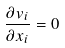Convert formula to latex. <formula><loc_0><loc_0><loc_500><loc_500>\frac { \partial v _ { i } } { \partial x _ { i } } = 0</formula> 